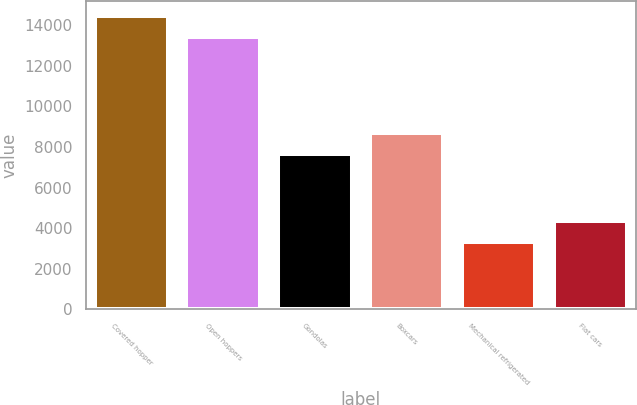Convert chart to OTSL. <chart><loc_0><loc_0><loc_500><loc_500><bar_chart><fcel>Covered hopper<fcel>Open hoppers<fcel>Gondolas<fcel>Boxcars<fcel>Mechanical refrigerated<fcel>Flat cars<nl><fcel>14486.5<fcel>13431<fcel>7639<fcel>8694.5<fcel>3309<fcel>4364.5<nl></chart> 